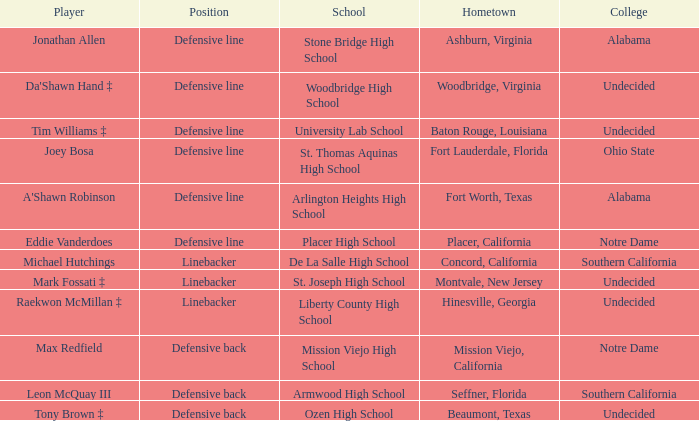What is the beaumont, texas player's position? Defensive back. 